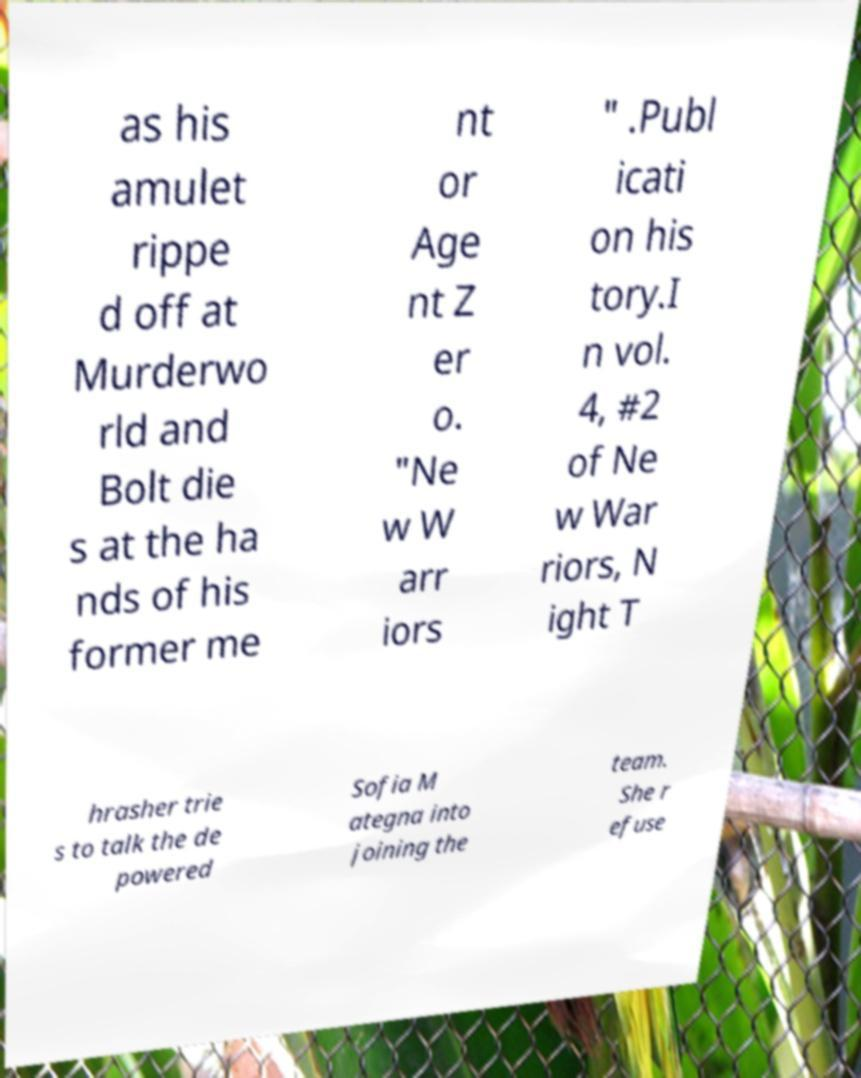What messages or text are displayed in this image? I need them in a readable, typed format. as his amulet rippe d off at Murderwo rld and Bolt die s at the ha nds of his former me nt or Age nt Z er o. "Ne w W arr iors " .Publ icati on his tory.I n vol. 4, #2 of Ne w War riors, N ight T hrasher trie s to talk the de powered Sofia M ategna into joining the team. She r efuse 